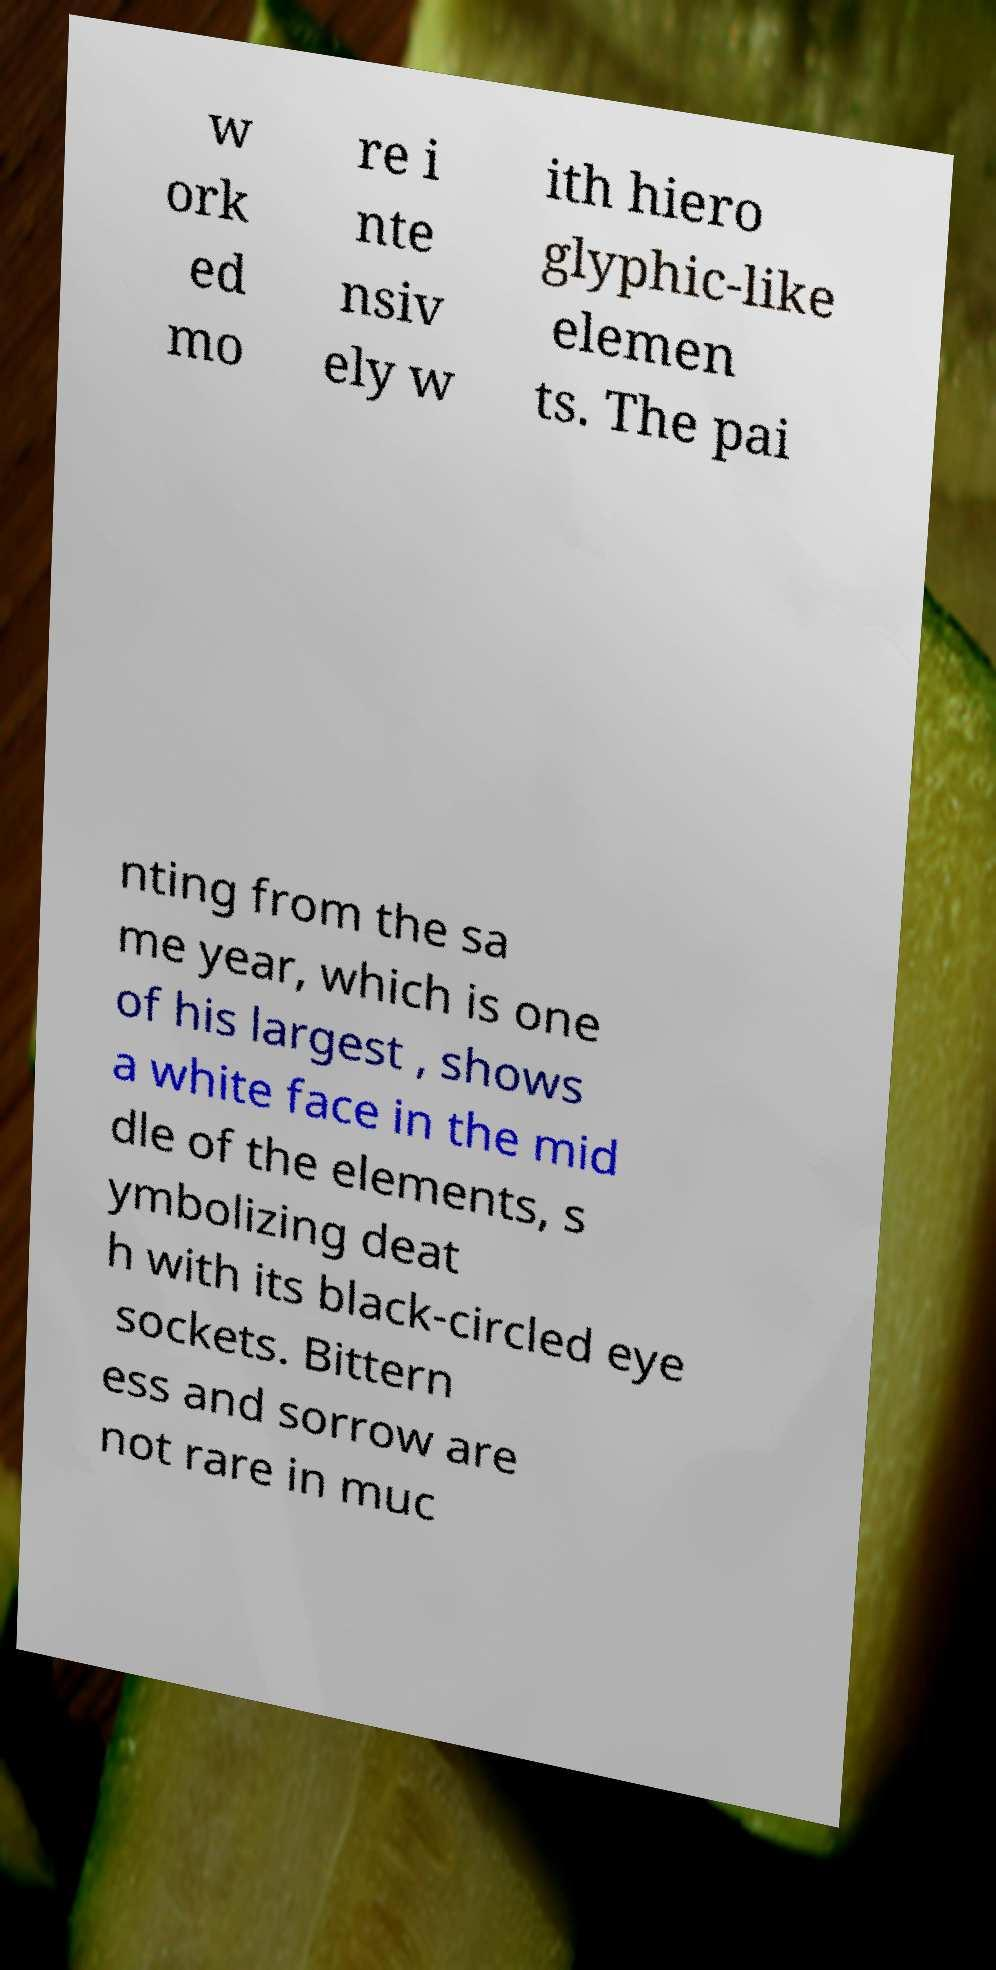Could you assist in decoding the text presented in this image and type it out clearly? w ork ed mo re i nte nsiv ely w ith hiero glyphic-like elemen ts. The pai nting from the sa me year, which is one of his largest , shows a white face in the mid dle of the elements, s ymbolizing deat h with its black-circled eye sockets. Bittern ess and sorrow are not rare in muc 